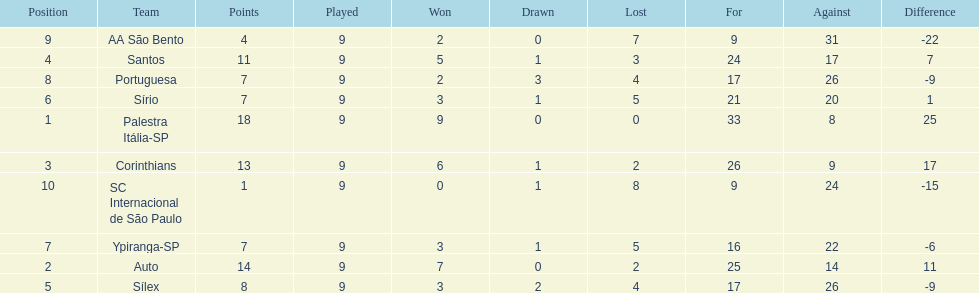How many teams played football in brazil during the year 1926? Palestra Itália-SP, Auto, Corinthians, Santos, Sílex, Sírio, Ypiranga-SP, Portuguesa, AA São Bento, SC Internacional de São Paulo. What was the highest number of games won during the 1926 season? 9. Which team was in the top spot with 9 wins for the 1926 season? Palestra Itália-SP. 